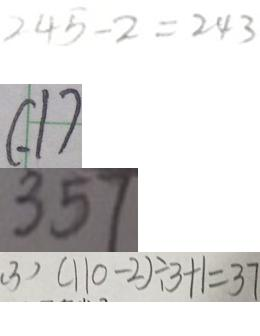Convert formula to latex. <formula><loc_0><loc_0><loc_500><loc_500>2 4 5 - 2 = 2 4 3 
 ( . 1 ) 
 3 5 7 
 ( 3 ) ( 1 1 0 - 2 ) \div 3 + 1 = 3 7</formula> 